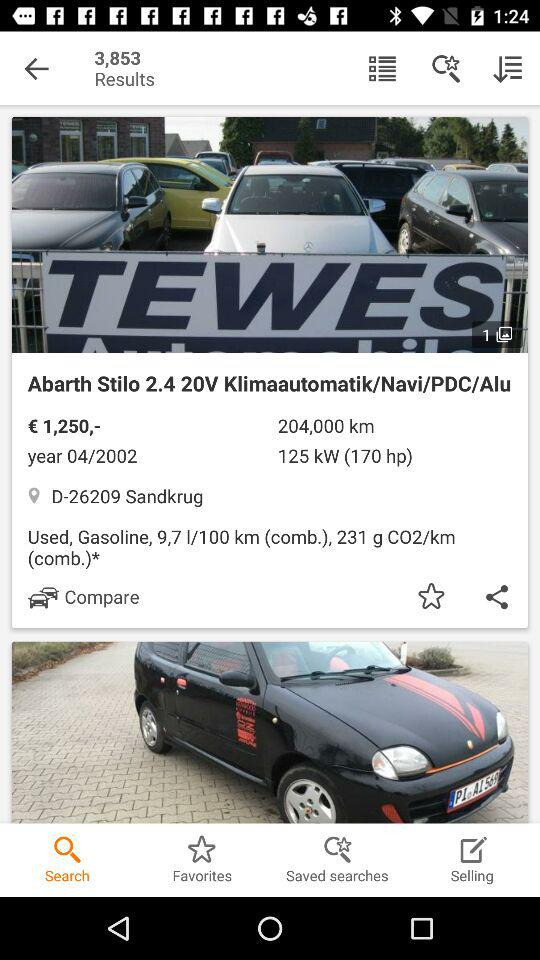What's the year? The year is 2002. 